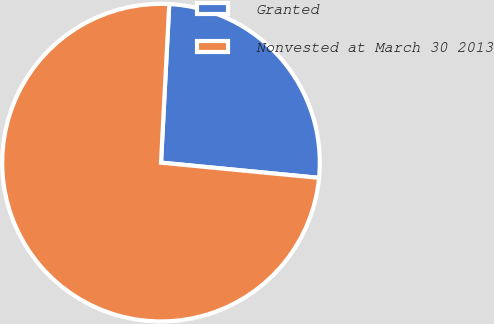Convert chart. <chart><loc_0><loc_0><loc_500><loc_500><pie_chart><fcel>Granted<fcel>Nonvested at March 30 2013<nl><fcel>25.7%<fcel>74.3%<nl></chart> 